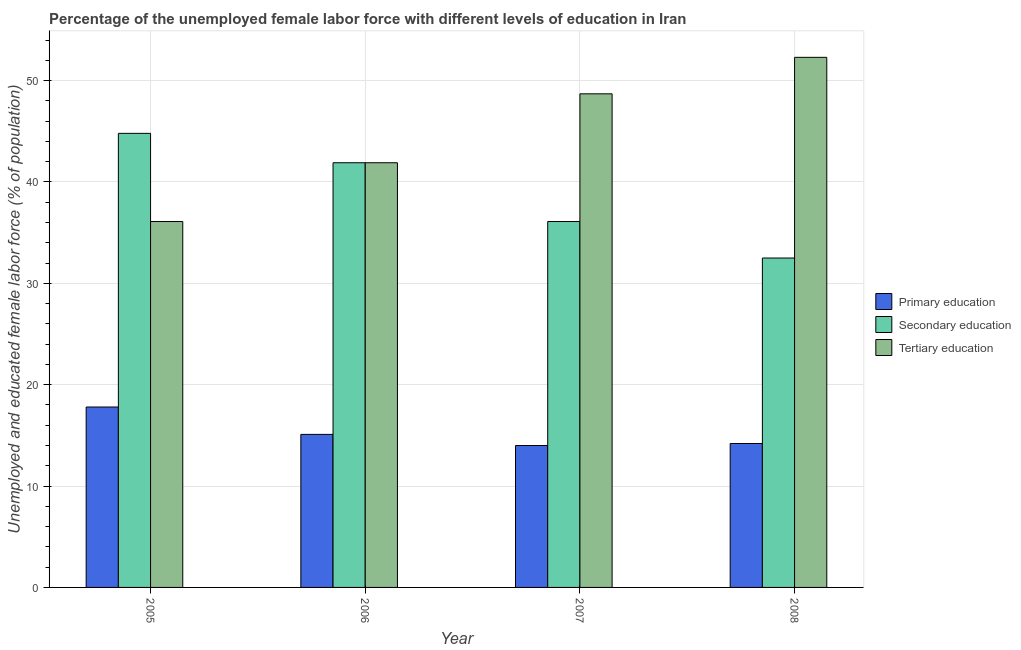How many groups of bars are there?
Offer a very short reply. 4. Are the number of bars on each tick of the X-axis equal?
Your answer should be compact. Yes. In how many cases, is the number of bars for a given year not equal to the number of legend labels?
Offer a very short reply. 0. What is the percentage of female labor force who received secondary education in 2006?
Ensure brevity in your answer.  41.9. Across all years, what is the maximum percentage of female labor force who received secondary education?
Your response must be concise. 44.8. Across all years, what is the minimum percentage of female labor force who received secondary education?
Give a very brief answer. 32.5. In which year was the percentage of female labor force who received tertiary education minimum?
Your answer should be very brief. 2005. What is the total percentage of female labor force who received tertiary education in the graph?
Provide a short and direct response. 179. What is the difference between the percentage of female labor force who received tertiary education in 2005 and that in 2007?
Provide a short and direct response. -12.6. What is the difference between the percentage of female labor force who received primary education in 2006 and the percentage of female labor force who received secondary education in 2008?
Your answer should be very brief. 0.9. What is the average percentage of female labor force who received primary education per year?
Your answer should be compact. 15.27. In the year 2008, what is the difference between the percentage of female labor force who received tertiary education and percentage of female labor force who received primary education?
Provide a succinct answer. 0. What is the ratio of the percentage of female labor force who received primary education in 2006 to that in 2007?
Offer a very short reply. 1.08. What is the difference between the highest and the second highest percentage of female labor force who received tertiary education?
Provide a succinct answer. 3.6. What is the difference between the highest and the lowest percentage of female labor force who received secondary education?
Keep it short and to the point. 12.3. In how many years, is the percentage of female labor force who received tertiary education greater than the average percentage of female labor force who received tertiary education taken over all years?
Keep it short and to the point. 2. Is the sum of the percentage of female labor force who received primary education in 2006 and 2008 greater than the maximum percentage of female labor force who received secondary education across all years?
Offer a terse response. Yes. What does the 3rd bar from the left in 2007 represents?
Provide a succinct answer. Tertiary education. Is it the case that in every year, the sum of the percentage of female labor force who received primary education and percentage of female labor force who received secondary education is greater than the percentage of female labor force who received tertiary education?
Keep it short and to the point. No. How many bars are there?
Provide a short and direct response. 12. Are all the bars in the graph horizontal?
Ensure brevity in your answer.  No. Does the graph contain grids?
Provide a succinct answer. Yes. What is the title of the graph?
Give a very brief answer. Percentage of the unemployed female labor force with different levels of education in Iran. What is the label or title of the X-axis?
Your answer should be very brief. Year. What is the label or title of the Y-axis?
Offer a terse response. Unemployed and educated female labor force (% of population). What is the Unemployed and educated female labor force (% of population) in Primary education in 2005?
Your answer should be compact. 17.8. What is the Unemployed and educated female labor force (% of population) in Secondary education in 2005?
Offer a terse response. 44.8. What is the Unemployed and educated female labor force (% of population) of Tertiary education in 2005?
Your answer should be compact. 36.1. What is the Unemployed and educated female labor force (% of population) in Primary education in 2006?
Your answer should be very brief. 15.1. What is the Unemployed and educated female labor force (% of population) in Secondary education in 2006?
Keep it short and to the point. 41.9. What is the Unemployed and educated female labor force (% of population) in Tertiary education in 2006?
Your response must be concise. 41.9. What is the Unemployed and educated female labor force (% of population) of Primary education in 2007?
Keep it short and to the point. 14. What is the Unemployed and educated female labor force (% of population) of Secondary education in 2007?
Make the answer very short. 36.1. What is the Unemployed and educated female labor force (% of population) in Tertiary education in 2007?
Offer a terse response. 48.7. What is the Unemployed and educated female labor force (% of population) of Primary education in 2008?
Make the answer very short. 14.2. What is the Unemployed and educated female labor force (% of population) of Secondary education in 2008?
Your response must be concise. 32.5. What is the Unemployed and educated female labor force (% of population) in Tertiary education in 2008?
Give a very brief answer. 52.3. Across all years, what is the maximum Unemployed and educated female labor force (% of population) of Primary education?
Make the answer very short. 17.8. Across all years, what is the maximum Unemployed and educated female labor force (% of population) of Secondary education?
Your answer should be compact. 44.8. Across all years, what is the maximum Unemployed and educated female labor force (% of population) in Tertiary education?
Your answer should be very brief. 52.3. Across all years, what is the minimum Unemployed and educated female labor force (% of population) in Primary education?
Your answer should be very brief. 14. Across all years, what is the minimum Unemployed and educated female labor force (% of population) in Secondary education?
Provide a short and direct response. 32.5. Across all years, what is the minimum Unemployed and educated female labor force (% of population) in Tertiary education?
Provide a succinct answer. 36.1. What is the total Unemployed and educated female labor force (% of population) of Primary education in the graph?
Make the answer very short. 61.1. What is the total Unemployed and educated female labor force (% of population) in Secondary education in the graph?
Make the answer very short. 155.3. What is the total Unemployed and educated female labor force (% of population) in Tertiary education in the graph?
Keep it short and to the point. 179. What is the difference between the Unemployed and educated female labor force (% of population) in Secondary education in 2005 and that in 2006?
Offer a very short reply. 2.9. What is the difference between the Unemployed and educated female labor force (% of population) of Primary education in 2005 and that in 2007?
Ensure brevity in your answer.  3.8. What is the difference between the Unemployed and educated female labor force (% of population) in Tertiary education in 2005 and that in 2008?
Provide a short and direct response. -16.2. What is the difference between the Unemployed and educated female labor force (% of population) in Primary education in 2006 and that in 2007?
Your answer should be very brief. 1.1. What is the difference between the Unemployed and educated female labor force (% of population) in Secondary education in 2006 and that in 2007?
Keep it short and to the point. 5.8. What is the difference between the Unemployed and educated female labor force (% of population) of Primary education in 2007 and that in 2008?
Your answer should be compact. -0.2. What is the difference between the Unemployed and educated female labor force (% of population) of Tertiary education in 2007 and that in 2008?
Your answer should be compact. -3.6. What is the difference between the Unemployed and educated female labor force (% of population) in Primary education in 2005 and the Unemployed and educated female labor force (% of population) in Secondary education in 2006?
Provide a succinct answer. -24.1. What is the difference between the Unemployed and educated female labor force (% of population) of Primary education in 2005 and the Unemployed and educated female labor force (% of population) of Tertiary education in 2006?
Make the answer very short. -24.1. What is the difference between the Unemployed and educated female labor force (% of population) in Secondary education in 2005 and the Unemployed and educated female labor force (% of population) in Tertiary education in 2006?
Your answer should be very brief. 2.9. What is the difference between the Unemployed and educated female labor force (% of population) of Primary education in 2005 and the Unemployed and educated female labor force (% of population) of Secondary education in 2007?
Keep it short and to the point. -18.3. What is the difference between the Unemployed and educated female labor force (% of population) of Primary education in 2005 and the Unemployed and educated female labor force (% of population) of Tertiary education in 2007?
Your response must be concise. -30.9. What is the difference between the Unemployed and educated female labor force (% of population) in Secondary education in 2005 and the Unemployed and educated female labor force (% of population) in Tertiary education in 2007?
Give a very brief answer. -3.9. What is the difference between the Unemployed and educated female labor force (% of population) of Primary education in 2005 and the Unemployed and educated female labor force (% of population) of Secondary education in 2008?
Give a very brief answer. -14.7. What is the difference between the Unemployed and educated female labor force (% of population) of Primary education in 2005 and the Unemployed and educated female labor force (% of population) of Tertiary education in 2008?
Keep it short and to the point. -34.5. What is the difference between the Unemployed and educated female labor force (% of population) of Secondary education in 2005 and the Unemployed and educated female labor force (% of population) of Tertiary education in 2008?
Make the answer very short. -7.5. What is the difference between the Unemployed and educated female labor force (% of population) in Primary education in 2006 and the Unemployed and educated female labor force (% of population) in Secondary education in 2007?
Offer a very short reply. -21. What is the difference between the Unemployed and educated female labor force (% of population) of Primary education in 2006 and the Unemployed and educated female labor force (% of population) of Tertiary education in 2007?
Provide a short and direct response. -33.6. What is the difference between the Unemployed and educated female labor force (% of population) in Primary education in 2006 and the Unemployed and educated female labor force (% of population) in Secondary education in 2008?
Your response must be concise. -17.4. What is the difference between the Unemployed and educated female labor force (% of population) of Primary education in 2006 and the Unemployed and educated female labor force (% of population) of Tertiary education in 2008?
Provide a short and direct response. -37.2. What is the difference between the Unemployed and educated female labor force (% of population) of Secondary education in 2006 and the Unemployed and educated female labor force (% of population) of Tertiary education in 2008?
Ensure brevity in your answer.  -10.4. What is the difference between the Unemployed and educated female labor force (% of population) of Primary education in 2007 and the Unemployed and educated female labor force (% of population) of Secondary education in 2008?
Give a very brief answer. -18.5. What is the difference between the Unemployed and educated female labor force (% of population) in Primary education in 2007 and the Unemployed and educated female labor force (% of population) in Tertiary education in 2008?
Give a very brief answer. -38.3. What is the difference between the Unemployed and educated female labor force (% of population) of Secondary education in 2007 and the Unemployed and educated female labor force (% of population) of Tertiary education in 2008?
Provide a succinct answer. -16.2. What is the average Unemployed and educated female labor force (% of population) in Primary education per year?
Make the answer very short. 15.28. What is the average Unemployed and educated female labor force (% of population) in Secondary education per year?
Your answer should be compact. 38.83. What is the average Unemployed and educated female labor force (% of population) of Tertiary education per year?
Provide a short and direct response. 44.75. In the year 2005, what is the difference between the Unemployed and educated female labor force (% of population) of Primary education and Unemployed and educated female labor force (% of population) of Secondary education?
Offer a very short reply. -27. In the year 2005, what is the difference between the Unemployed and educated female labor force (% of population) in Primary education and Unemployed and educated female labor force (% of population) in Tertiary education?
Offer a very short reply. -18.3. In the year 2006, what is the difference between the Unemployed and educated female labor force (% of population) of Primary education and Unemployed and educated female labor force (% of population) of Secondary education?
Your answer should be very brief. -26.8. In the year 2006, what is the difference between the Unemployed and educated female labor force (% of population) of Primary education and Unemployed and educated female labor force (% of population) of Tertiary education?
Give a very brief answer. -26.8. In the year 2006, what is the difference between the Unemployed and educated female labor force (% of population) of Secondary education and Unemployed and educated female labor force (% of population) of Tertiary education?
Make the answer very short. 0. In the year 2007, what is the difference between the Unemployed and educated female labor force (% of population) in Primary education and Unemployed and educated female labor force (% of population) in Secondary education?
Give a very brief answer. -22.1. In the year 2007, what is the difference between the Unemployed and educated female labor force (% of population) of Primary education and Unemployed and educated female labor force (% of population) of Tertiary education?
Your answer should be very brief. -34.7. In the year 2008, what is the difference between the Unemployed and educated female labor force (% of population) of Primary education and Unemployed and educated female labor force (% of population) of Secondary education?
Keep it short and to the point. -18.3. In the year 2008, what is the difference between the Unemployed and educated female labor force (% of population) of Primary education and Unemployed and educated female labor force (% of population) of Tertiary education?
Provide a short and direct response. -38.1. In the year 2008, what is the difference between the Unemployed and educated female labor force (% of population) of Secondary education and Unemployed and educated female labor force (% of population) of Tertiary education?
Keep it short and to the point. -19.8. What is the ratio of the Unemployed and educated female labor force (% of population) of Primary education in 2005 to that in 2006?
Ensure brevity in your answer.  1.18. What is the ratio of the Unemployed and educated female labor force (% of population) of Secondary education in 2005 to that in 2006?
Ensure brevity in your answer.  1.07. What is the ratio of the Unemployed and educated female labor force (% of population) in Tertiary education in 2005 to that in 2006?
Your answer should be very brief. 0.86. What is the ratio of the Unemployed and educated female labor force (% of population) of Primary education in 2005 to that in 2007?
Provide a short and direct response. 1.27. What is the ratio of the Unemployed and educated female labor force (% of population) in Secondary education in 2005 to that in 2007?
Ensure brevity in your answer.  1.24. What is the ratio of the Unemployed and educated female labor force (% of population) in Tertiary education in 2005 to that in 2007?
Ensure brevity in your answer.  0.74. What is the ratio of the Unemployed and educated female labor force (% of population) in Primary education in 2005 to that in 2008?
Offer a terse response. 1.25. What is the ratio of the Unemployed and educated female labor force (% of population) of Secondary education in 2005 to that in 2008?
Your response must be concise. 1.38. What is the ratio of the Unemployed and educated female labor force (% of population) of Tertiary education in 2005 to that in 2008?
Give a very brief answer. 0.69. What is the ratio of the Unemployed and educated female labor force (% of population) in Primary education in 2006 to that in 2007?
Make the answer very short. 1.08. What is the ratio of the Unemployed and educated female labor force (% of population) of Secondary education in 2006 to that in 2007?
Your answer should be very brief. 1.16. What is the ratio of the Unemployed and educated female labor force (% of population) of Tertiary education in 2006 to that in 2007?
Your answer should be compact. 0.86. What is the ratio of the Unemployed and educated female labor force (% of population) of Primary education in 2006 to that in 2008?
Your answer should be compact. 1.06. What is the ratio of the Unemployed and educated female labor force (% of population) in Secondary education in 2006 to that in 2008?
Your answer should be very brief. 1.29. What is the ratio of the Unemployed and educated female labor force (% of population) of Tertiary education in 2006 to that in 2008?
Provide a succinct answer. 0.8. What is the ratio of the Unemployed and educated female labor force (% of population) of Primary education in 2007 to that in 2008?
Offer a terse response. 0.99. What is the ratio of the Unemployed and educated female labor force (% of population) in Secondary education in 2007 to that in 2008?
Provide a succinct answer. 1.11. What is the ratio of the Unemployed and educated female labor force (% of population) of Tertiary education in 2007 to that in 2008?
Your answer should be very brief. 0.93. What is the difference between the highest and the second highest Unemployed and educated female labor force (% of population) in Secondary education?
Offer a very short reply. 2.9. What is the difference between the highest and the lowest Unemployed and educated female labor force (% of population) in Primary education?
Your answer should be very brief. 3.8. What is the difference between the highest and the lowest Unemployed and educated female labor force (% of population) in Secondary education?
Your answer should be compact. 12.3. What is the difference between the highest and the lowest Unemployed and educated female labor force (% of population) in Tertiary education?
Give a very brief answer. 16.2. 